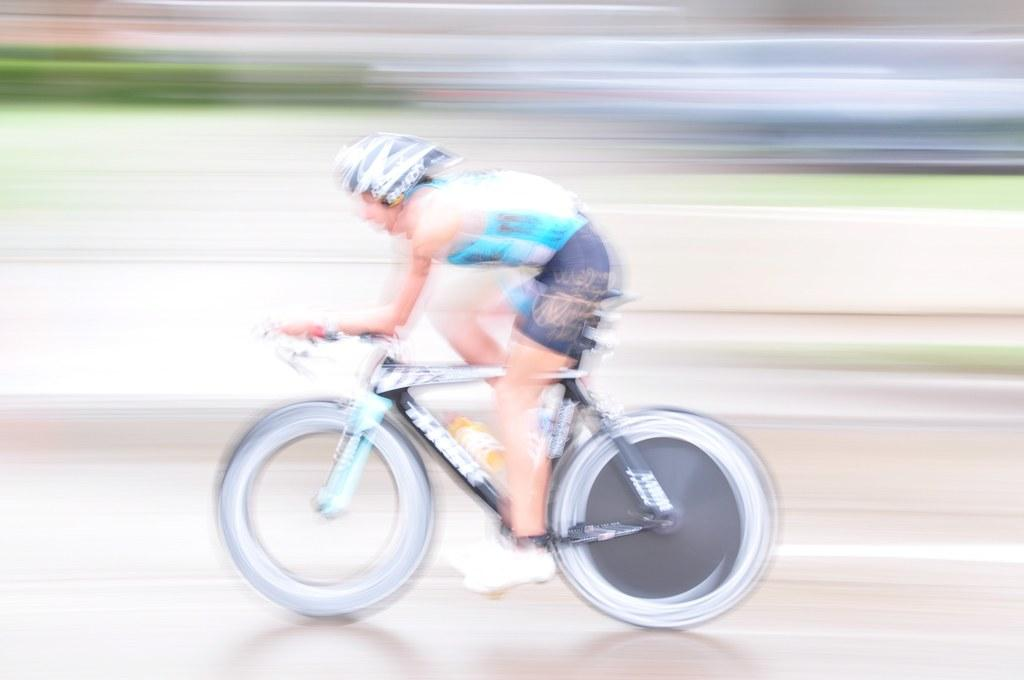Who is the main subject in the image? There is a man in the image. What is the man wearing? The man is wearing a blue t-shirt. What activity is the man engaged in? The man is riding a bicycle. Can you describe the background of the image? The background of the image is blurred. How many crows can be seen flying in the image? There are no crows present in the image. What type of birds can be seen in the image? There are no birds visible in the image. 